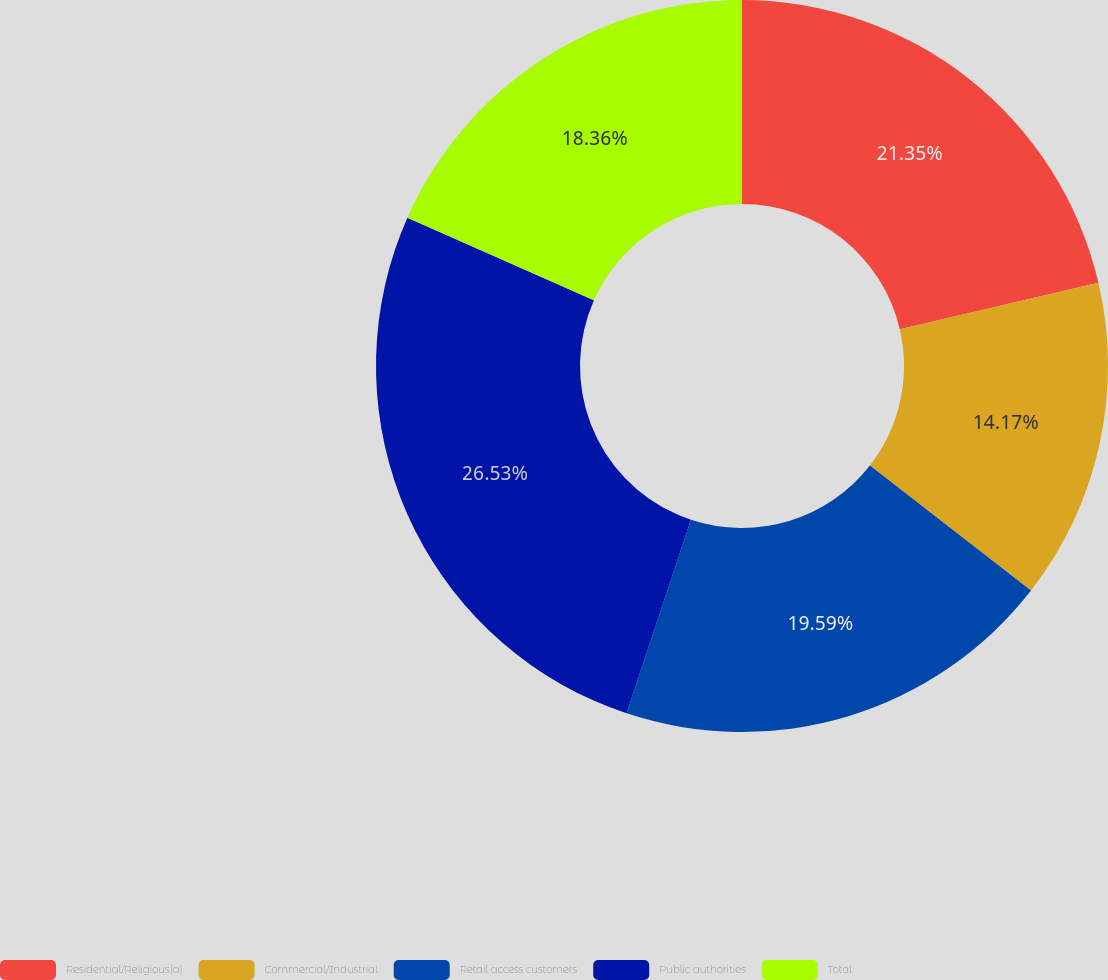<chart> <loc_0><loc_0><loc_500><loc_500><pie_chart><fcel>Residential/Religious(a)<fcel>Commercial/Industrial<fcel>Retail access customers<fcel>Public authorities<fcel>Total<nl><fcel>21.35%<fcel>14.17%<fcel>19.59%<fcel>26.54%<fcel>18.36%<nl></chart> 